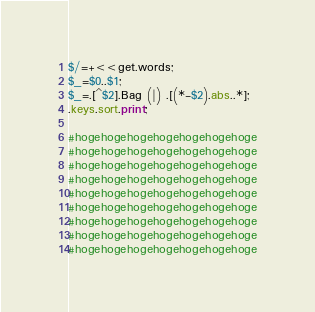Convert code to text. <code><loc_0><loc_0><loc_500><loc_500><_Perl_>$/=+<<get.words;
$_=$0..$1;
$_=.[^$2].Bag (|) .[(*-$2).abs..*];
.keys.sort.print;

#hogehogehogehogehogehogehoge
#hogehogehogehogehogehogehoge
#hogehogehogehogehogehogehoge
#hogehogehogehogehogehogehoge
#hogehogehogehogehogehogehoge
#hogehogehogehogehogehogehoge
#hogehogehogehogehogehogehoge
#hogehogehogehogehogehogehoge
#hogehogehogehogehogehogehoge</code> 